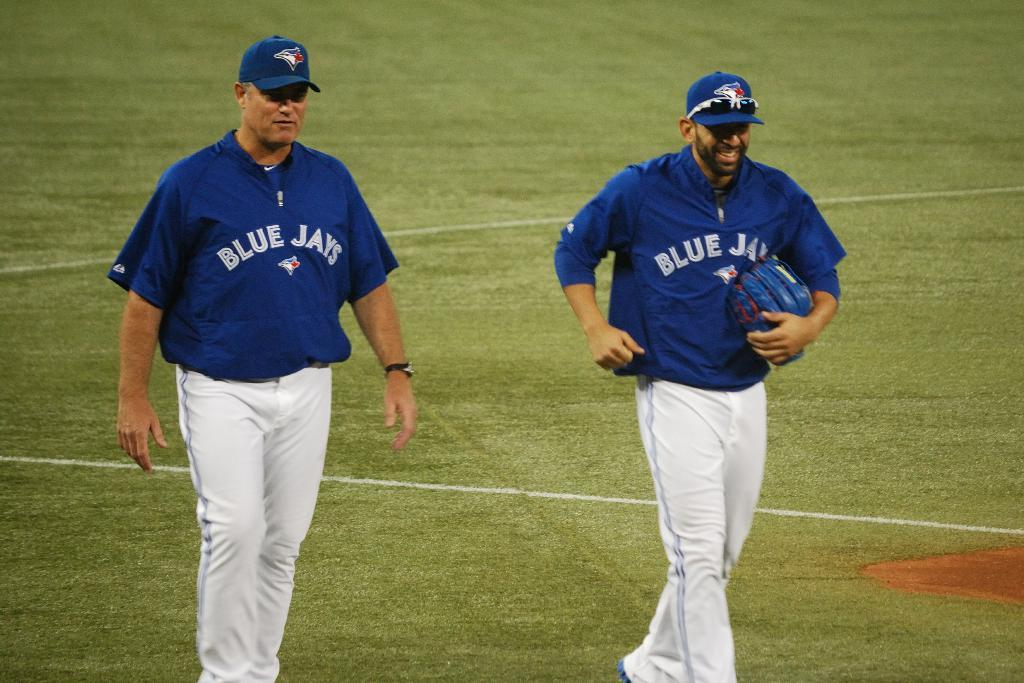<image>
Present a compact description of the photo's key features. Two Blu Jays players walk side by side on a ballfield. 